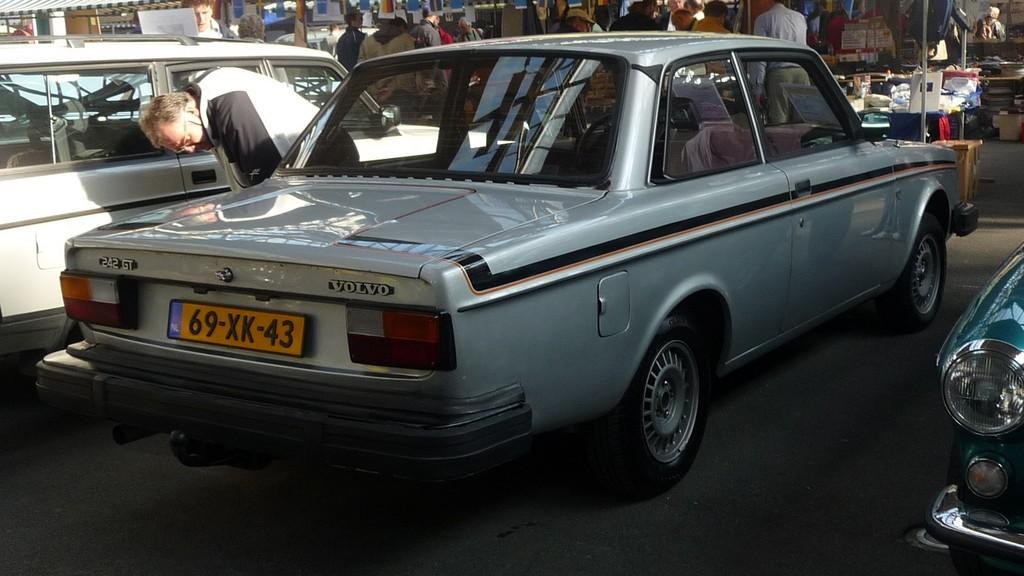What can be seen in the image? There are vehicles in the image. Can you describe the person in the image? There is a person on the ground in the image. What else is visible in the background of the image? There are persons and other objects in the background of the image. What type of stove is being used by the person in the image? There is no stove present in the image. How does the industry affect the growth of the person in the image? There is no reference to an industry or growth in the image. 